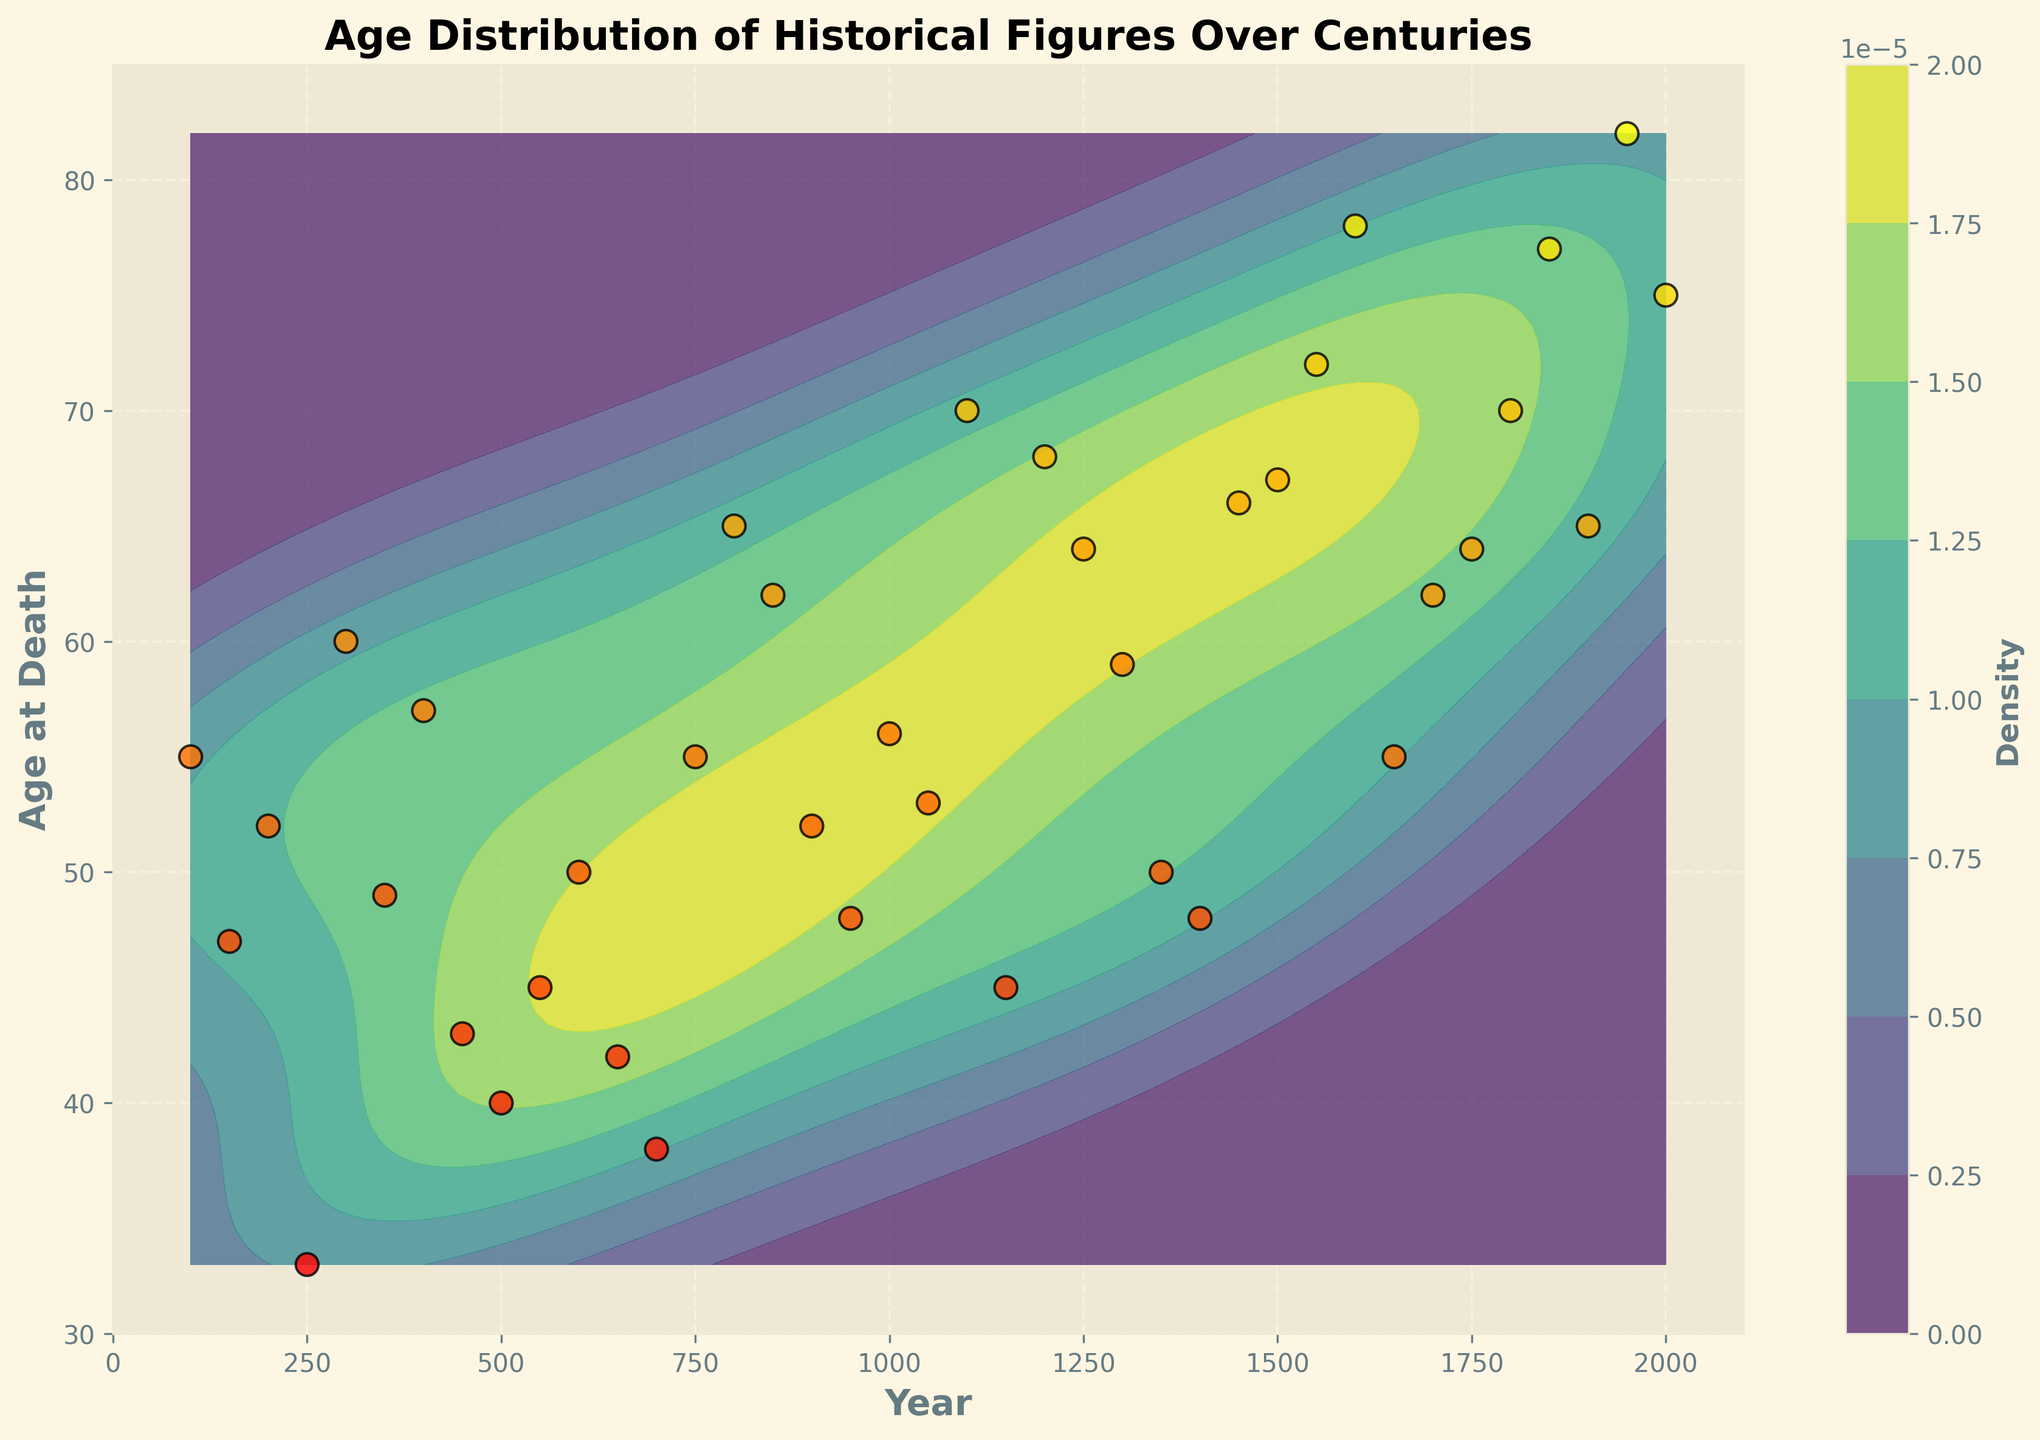What's the title of the figure? The title is usually displayed at the top of the figure. In this case, the title is "Age Distribution of Historical Figures Over Centuries" as explicitly stated in the code.
Answer: Age Distribution of Historical Figures Over Centuries What is the range of the y-axis? The range of the y-axis can be determined by looking at the values on the y-axis. According to the code, the y-axis limit is set from 30 to 85.
Answer: 30 to 85 Which age at death has the highest density for historical figures around the year 1500? To determine this, look at the contour density plot around the year 1500 on the x-axis and observe the highest density regions indicated by darker colors. The highest density appears around age 67.
Answer: 67 How does the age distribution of historical figures change over time? Observing the contour density plot from left (earlier years) to right (more recent years), one can see an increasing density for higher ages at death. In earlier periods, ages at death are more spread out, while in more recent times, higher ages (70+) become more frequent.
Answer: Increasing over time What is the pattern of data points around the year 2000? Refer to the scatter plot elements. Around the year 2000, data points are concentrated at higher ages at death, around age 75 and above.
Answer: High concentration around 75+ Which historical period shows a significant increase in the age at death density? By following the contour density from one period to another, the period around the 17th century (around year 1600) shows a notable increase in density at higher ages at death.
Answer: 17th century What age group had the least density in the 12th century (around 1100)? To find this, check the contour density plot around the year 1100 and observe the lighter areas. The least density is observed in the lower age groups, specifically around age 45.
Answer: Around 45 Are there more historical figures dying at an older age in recent centuries compared to earlier centuries? Compare the density regions from earlier centuries to recent centuries. Recent centuries (e.g., around 1900 and onwards) show higher density in older age groups (>70) compared to earlier centuries, which had more density in lower age groups.
Answer: Yes What is the age at death range for figures around the year 800? Observe the scatter plot and contour density close to the year 800. The range is between approximately 55 and 65 years.
Answer: 55 to 65 Which century shows the most diverse age at death based on the plot? Examine the spread of points and contours for each century. The 20th century (around 1900) shows a wider distribution in age at death, indicating high diversity.
Answer: 20th century (around 1900) 